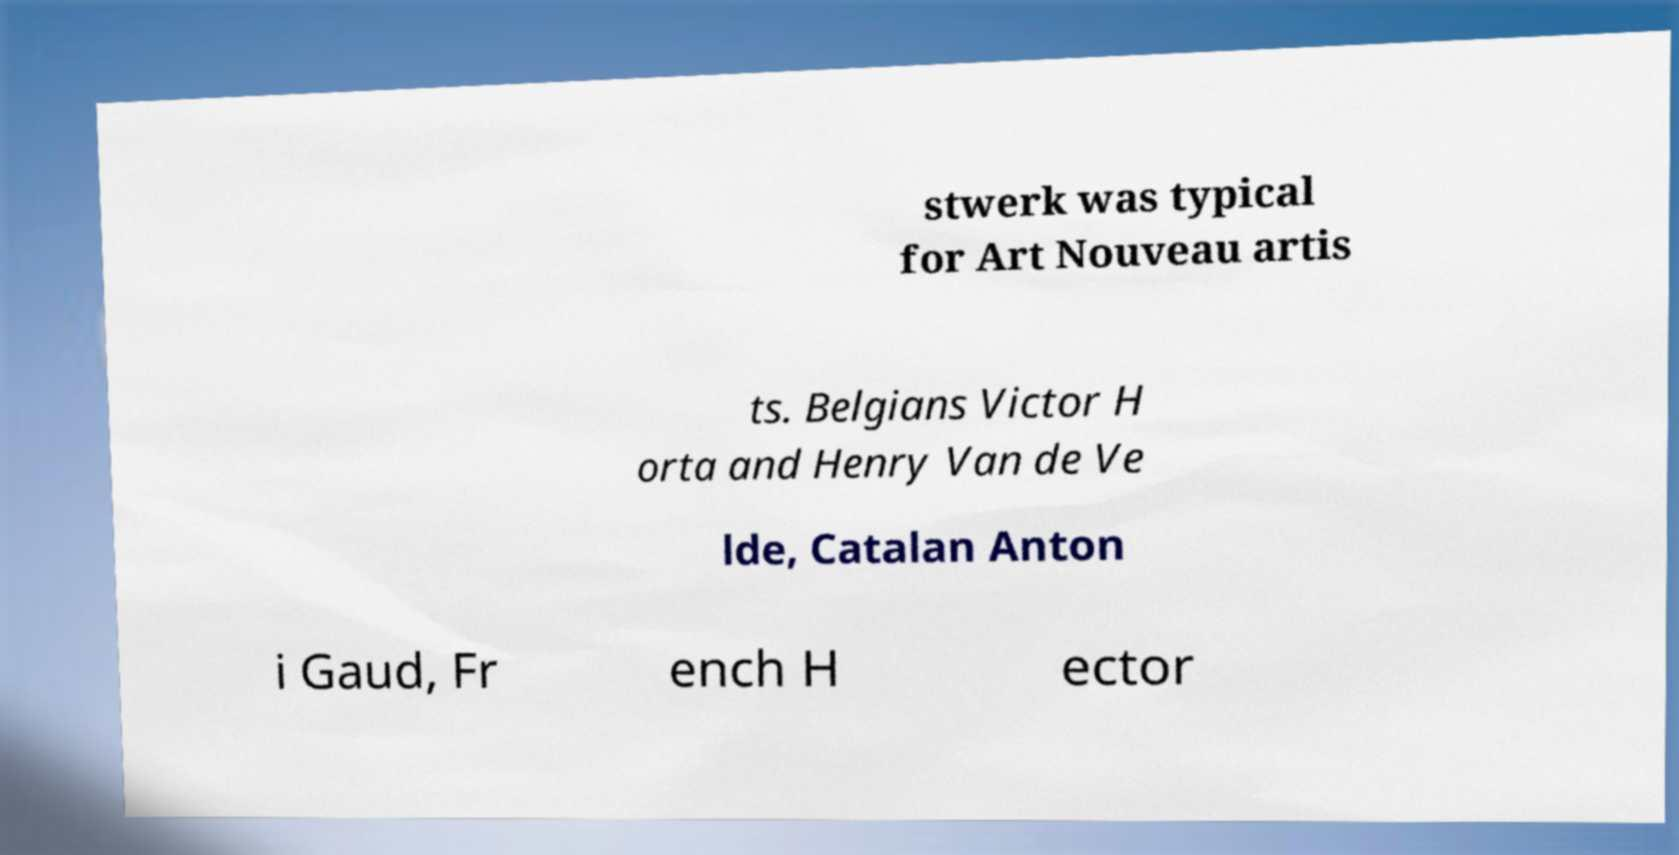I need the written content from this picture converted into text. Can you do that? stwerk was typical for Art Nouveau artis ts. Belgians Victor H orta and Henry Van de Ve lde, Catalan Anton i Gaud, Fr ench H ector 